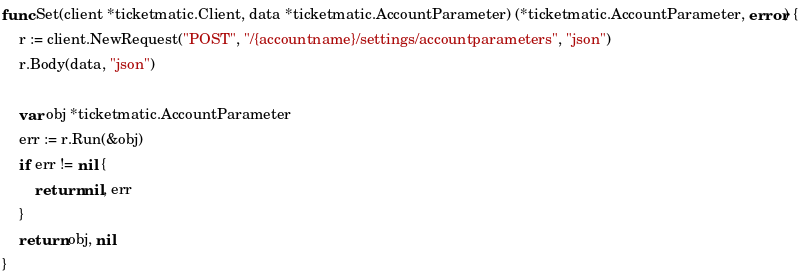<code> <loc_0><loc_0><loc_500><loc_500><_Go_>func Set(client *ticketmatic.Client, data *ticketmatic.AccountParameter) (*ticketmatic.AccountParameter, error) {
	r := client.NewRequest("POST", "/{accountname}/settings/accountparameters", "json")
	r.Body(data, "json")

	var obj *ticketmatic.AccountParameter
	err := r.Run(&obj)
	if err != nil {
		return nil, err
	}
	return obj, nil
}
</code> 